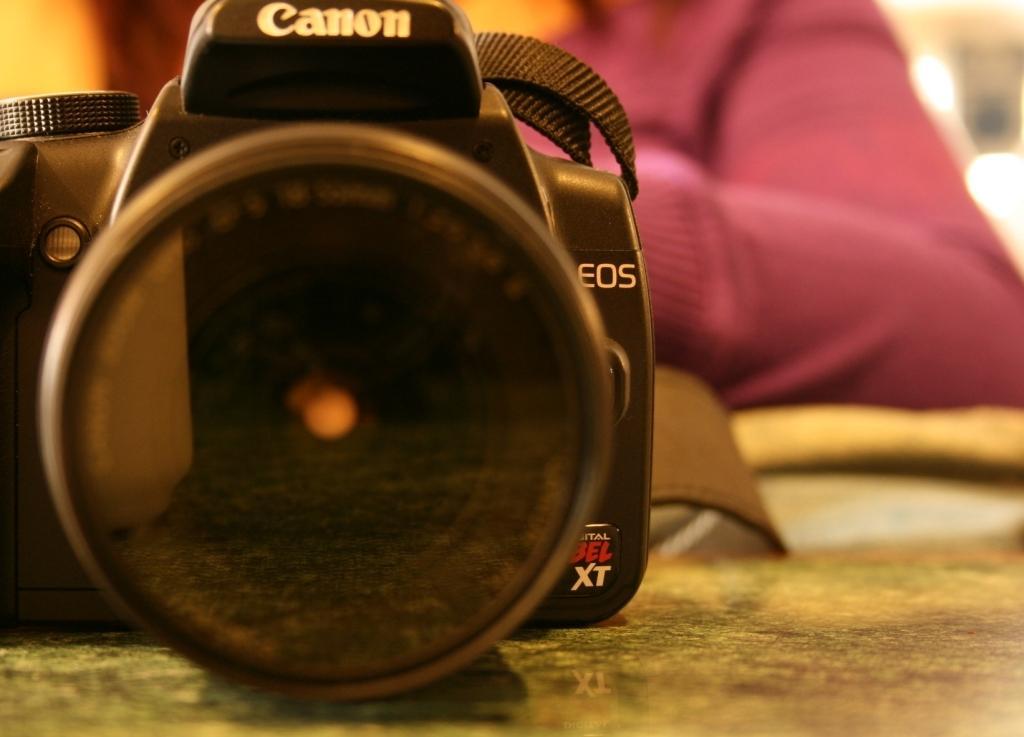In one or two sentences, can you explain what this image depicts? In this image we can see a camera is placed on the surface. The background of the image is blurred, where we can see a person wearing maroon color dress. 